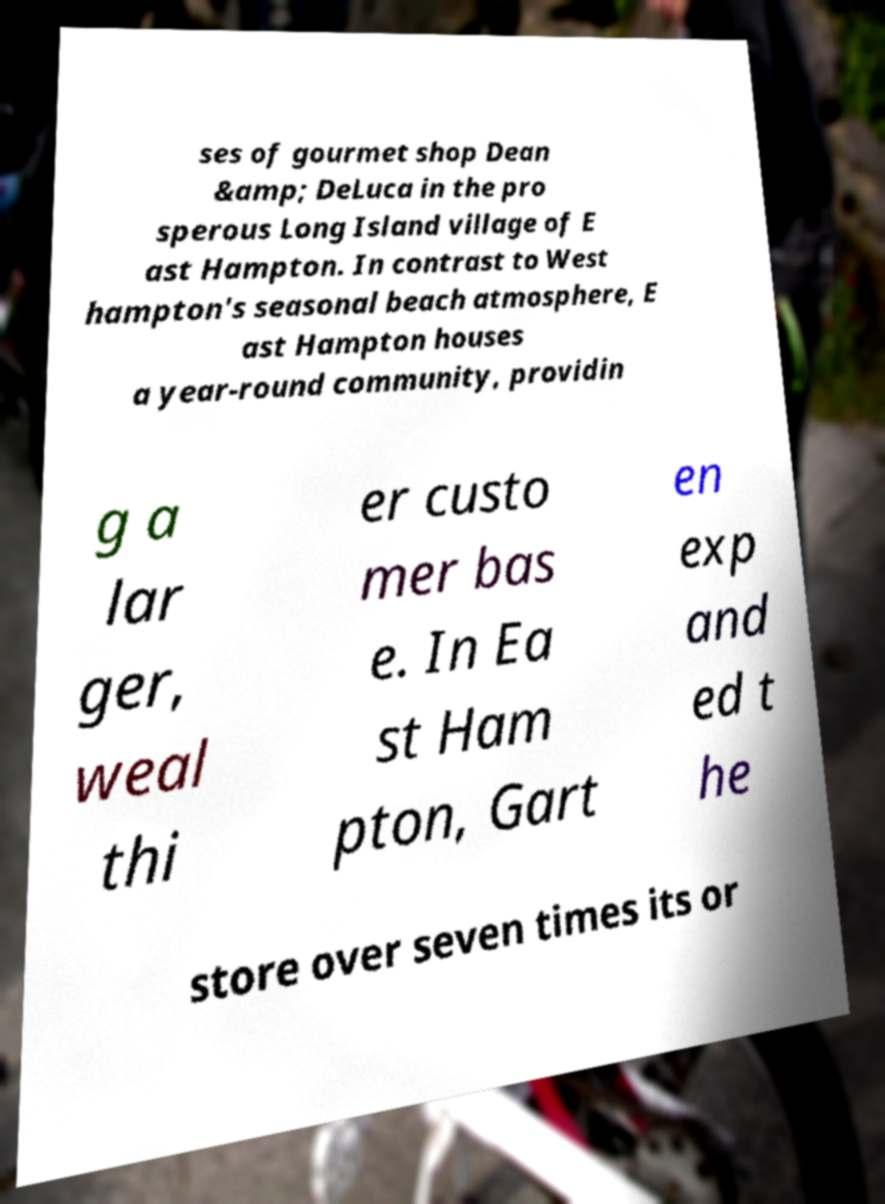Please identify and transcribe the text found in this image. ses of gourmet shop Dean &amp; DeLuca in the pro sperous Long Island village of E ast Hampton. In contrast to West hampton's seasonal beach atmosphere, E ast Hampton houses a year-round community, providin g a lar ger, weal thi er custo mer bas e. In Ea st Ham pton, Gart en exp and ed t he store over seven times its or 